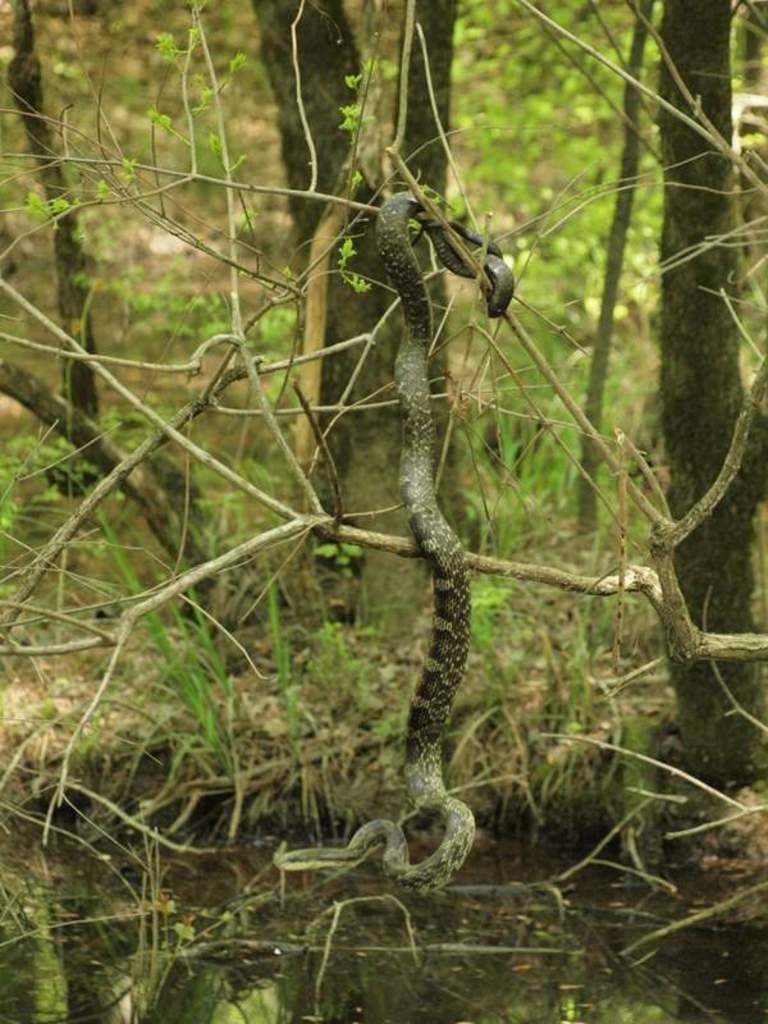Could you give a brief overview of what you see in this image? In this picture there is a snake which is hanging from this plant. At the bottom there is a water. In the background we can see trees, plants and grass. 